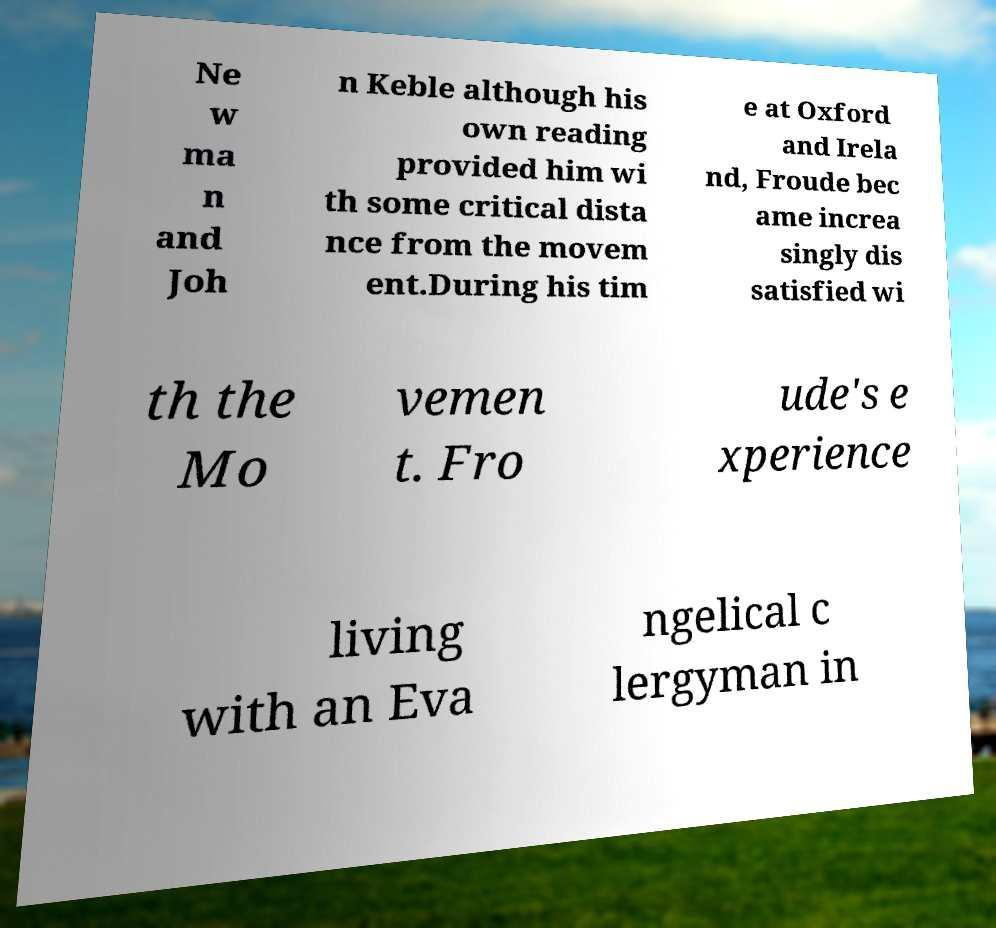Please identify and transcribe the text found in this image. Ne w ma n and Joh n Keble although his own reading provided him wi th some critical dista nce from the movem ent.During his tim e at Oxford and Irela nd, Froude bec ame increa singly dis satisfied wi th the Mo vemen t. Fro ude's e xperience living with an Eva ngelical c lergyman in 